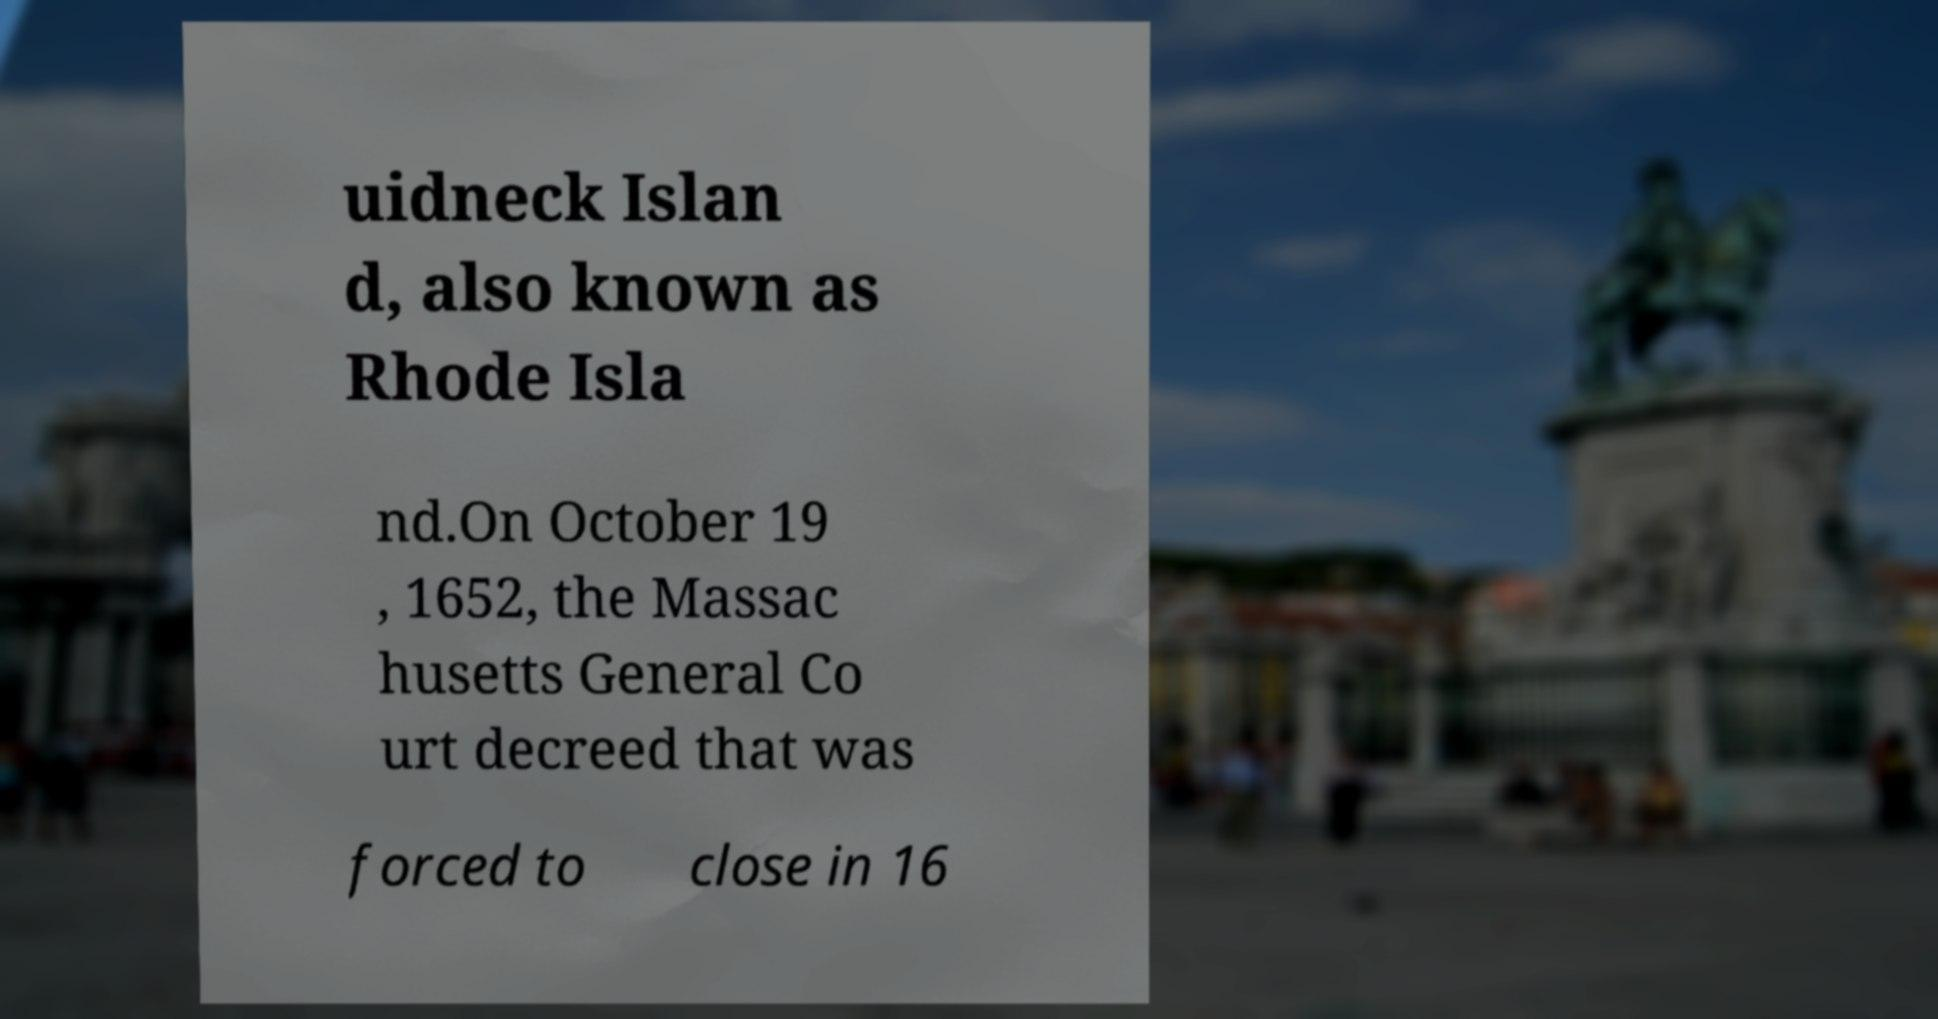For documentation purposes, I need the text within this image transcribed. Could you provide that? uidneck Islan d, also known as Rhode Isla nd.On October 19 , 1652, the Massac husetts General Co urt decreed that was forced to close in 16 